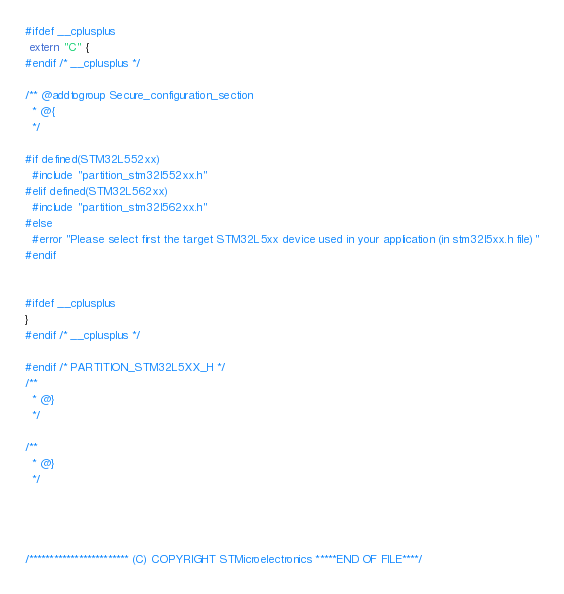Convert code to text. <code><loc_0><loc_0><loc_500><loc_500><_C_>#ifdef __cplusplus
 extern "C" {
#endif /* __cplusplus */

/** @addtogroup Secure_configuration_section
  * @{
  */

#if defined(STM32L552xx)
  #include "partition_stm32l552xx.h"
#elif defined(STM32L562xx)
  #include "partition_stm32l562xx.h"
#else
  #error "Please select first the target STM32L5xx device used in your application (in stm32l5xx.h file)"
#endif


#ifdef __cplusplus
}
#endif /* __cplusplus */

#endif /* PARTITION_STM32L5XX_H */
/**
  * @}
  */

/**
  * @}
  */




/************************ (C) COPYRIGHT STMicroelectronics *****END OF FILE****/
</code> 